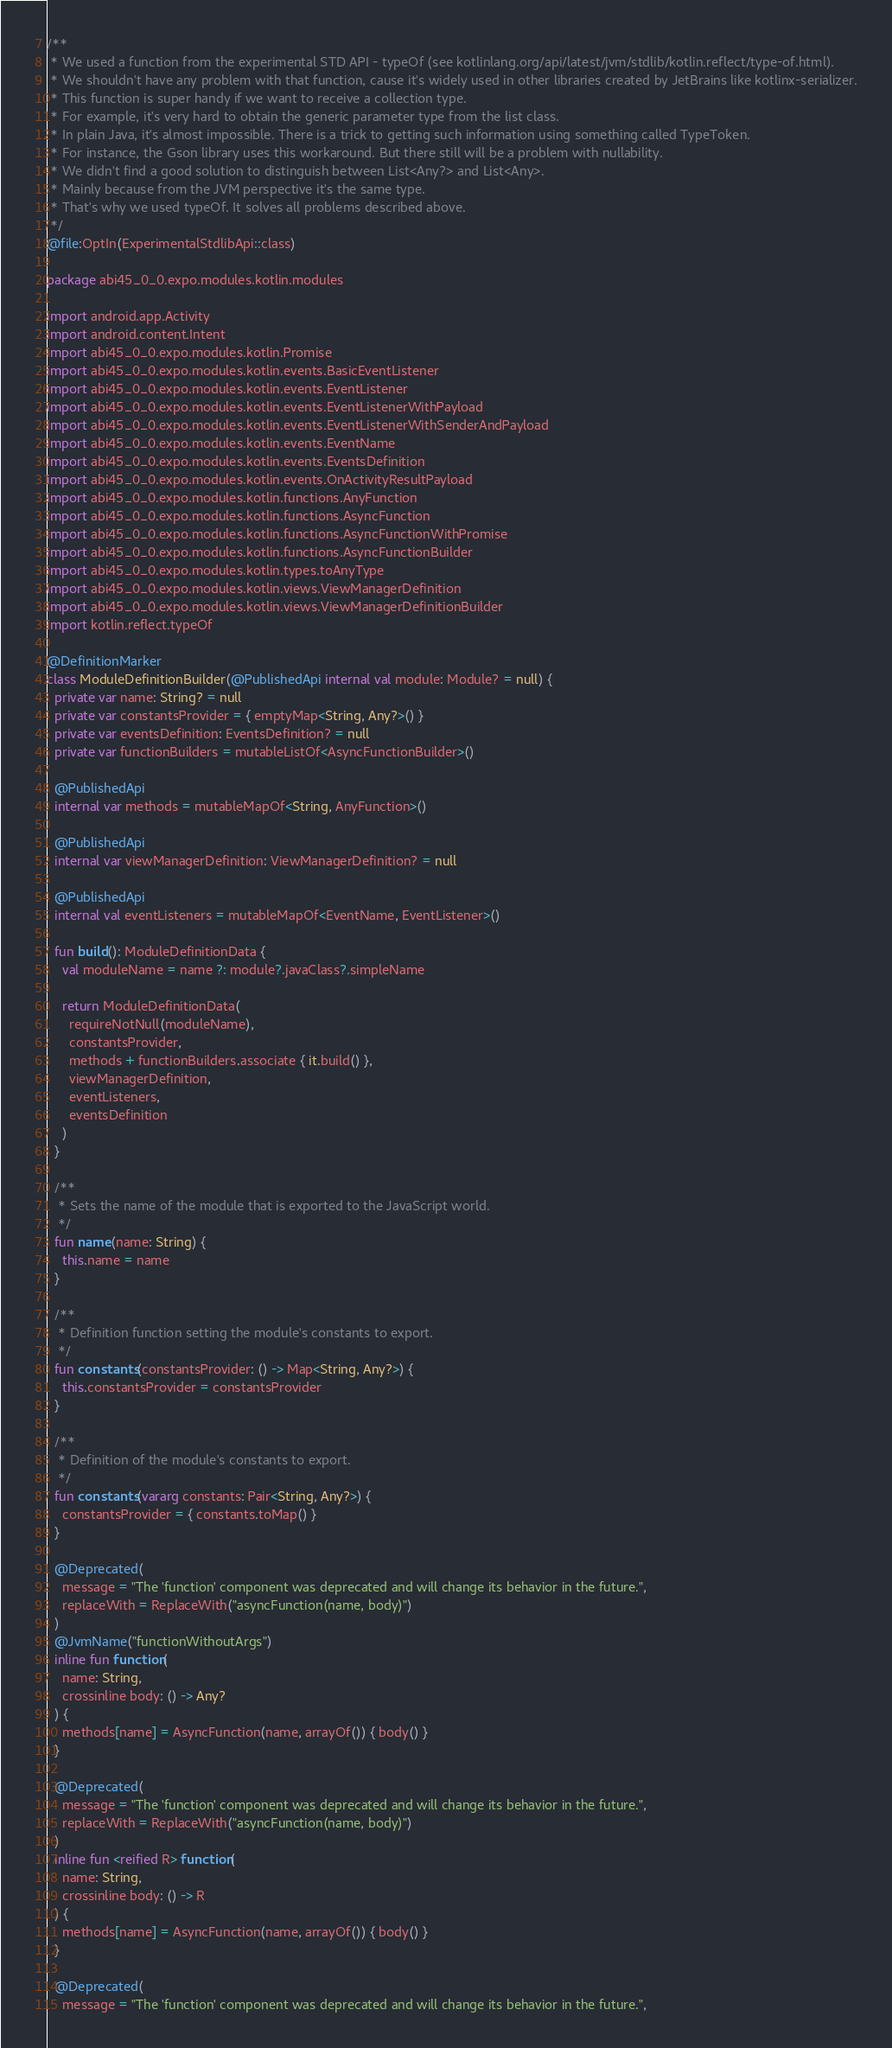<code> <loc_0><loc_0><loc_500><loc_500><_Kotlin_>/**
 * We used a function from the experimental STD API - typeOf (see kotlinlang.org/api/latest/jvm/stdlib/kotlin.reflect/type-of.html).
 * We shouldn't have any problem with that function, cause it's widely used in other libraries created by JetBrains like kotlinx-serializer.
 * This function is super handy if we want to receive a collection type.
 * For example, it's very hard to obtain the generic parameter type from the list class.
 * In plain Java, it's almost impossible. There is a trick to getting such information using something called TypeToken.
 * For instance, the Gson library uses this workaround. But there still will be a problem with nullability.
 * We didn't find a good solution to distinguish between List<Any?> and List<Any>.
 * Mainly because from the JVM perspective it's the same type.
 * That's why we used typeOf. It solves all problems described above.
 */
@file:OptIn(ExperimentalStdlibApi::class)

package abi45_0_0.expo.modules.kotlin.modules

import android.app.Activity
import android.content.Intent
import abi45_0_0.expo.modules.kotlin.Promise
import abi45_0_0.expo.modules.kotlin.events.BasicEventListener
import abi45_0_0.expo.modules.kotlin.events.EventListener
import abi45_0_0.expo.modules.kotlin.events.EventListenerWithPayload
import abi45_0_0.expo.modules.kotlin.events.EventListenerWithSenderAndPayload
import abi45_0_0.expo.modules.kotlin.events.EventName
import abi45_0_0.expo.modules.kotlin.events.EventsDefinition
import abi45_0_0.expo.modules.kotlin.events.OnActivityResultPayload
import abi45_0_0.expo.modules.kotlin.functions.AnyFunction
import abi45_0_0.expo.modules.kotlin.functions.AsyncFunction
import abi45_0_0.expo.modules.kotlin.functions.AsyncFunctionWithPromise
import abi45_0_0.expo.modules.kotlin.functions.AsyncFunctionBuilder
import abi45_0_0.expo.modules.kotlin.types.toAnyType
import abi45_0_0.expo.modules.kotlin.views.ViewManagerDefinition
import abi45_0_0.expo.modules.kotlin.views.ViewManagerDefinitionBuilder
import kotlin.reflect.typeOf

@DefinitionMarker
class ModuleDefinitionBuilder(@PublishedApi internal val module: Module? = null) {
  private var name: String? = null
  private var constantsProvider = { emptyMap<String, Any?>() }
  private var eventsDefinition: EventsDefinition? = null
  private var functionBuilders = mutableListOf<AsyncFunctionBuilder>()

  @PublishedApi
  internal var methods = mutableMapOf<String, AnyFunction>()

  @PublishedApi
  internal var viewManagerDefinition: ViewManagerDefinition? = null

  @PublishedApi
  internal val eventListeners = mutableMapOf<EventName, EventListener>()

  fun build(): ModuleDefinitionData {
    val moduleName = name ?: module?.javaClass?.simpleName

    return ModuleDefinitionData(
      requireNotNull(moduleName),
      constantsProvider,
      methods + functionBuilders.associate { it.build() },
      viewManagerDefinition,
      eventListeners,
      eventsDefinition
    )
  }

  /**
   * Sets the name of the module that is exported to the JavaScript world.
   */
  fun name(name: String) {
    this.name = name
  }

  /**
   * Definition function setting the module's constants to export.
   */
  fun constants(constantsProvider: () -> Map<String, Any?>) {
    this.constantsProvider = constantsProvider
  }

  /**
   * Definition of the module's constants to export.
   */
  fun constants(vararg constants: Pair<String, Any?>) {
    constantsProvider = { constants.toMap() }
  }

  @Deprecated(
    message = "The 'function' component was deprecated and will change its behavior in the future.",
    replaceWith = ReplaceWith("asyncFunction(name, body)")
  )
  @JvmName("functionWithoutArgs")
  inline fun function(
    name: String,
    crossinline body: () -> Any?
  ) {
    methods[name] = AsyncFunction(name, arrayOf()) { body() }
  }

  @Deprecated(
    message = "The 'function' component was deprecated and will change its behavior in the future.",
    replaceWith = ReplaceWith("asyncFunction(name, body)")
  )
  inline fun <reified R> function(
    name: String,
    crossinline body: () -> R
  ) {
    methods[name] = AsyncFunction(name, arrayOf()) { body() }
  }

  @Deprecated(
    message = "The 'function' component was deprecated and will change its behavior in the future.",</code> 